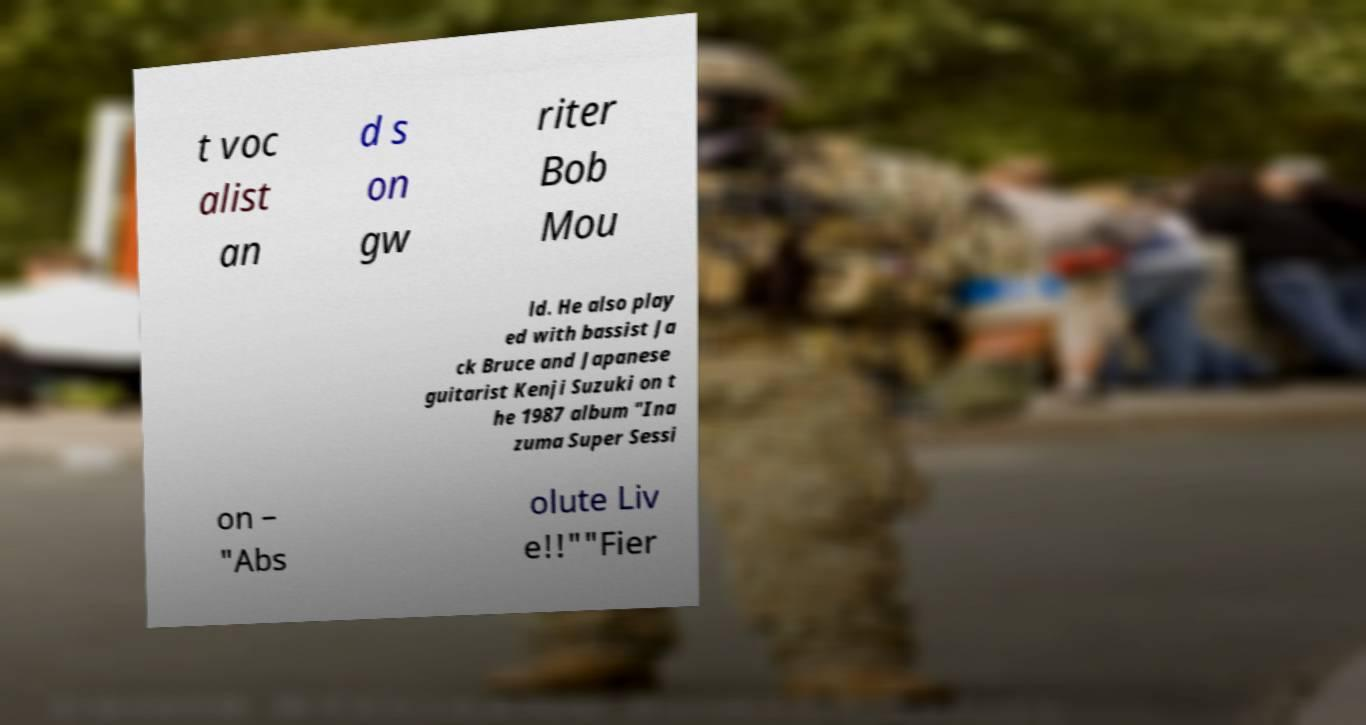Could you extract and type out the text from this image? t voc alist an d s on gw riter Bob Mou ld. He also play ed with bassist Ja ck Bruce and Japanese guitarist Kenji Suzuki on t he 1987 album "Ina zuma Super Sessi on – "Abs olute Liv e!!""Fier 